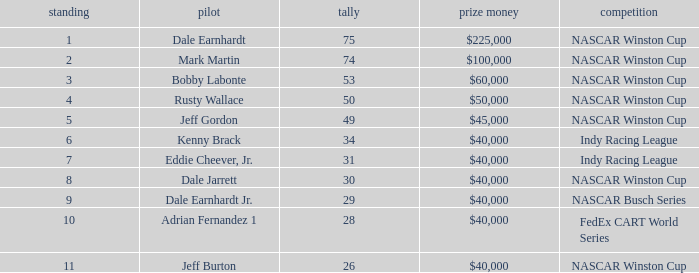How much did Kenny Brack win? $40,000. Give me the full table as a dictionary. {'header': ['standing', 'pilot', 'tally', 'prize money', 'competition'], 'rows': [['1', 'Dale Earnhardt', '75', '$225,000', 'NASCAR Winston Cup'], ['2', 'Mark Martin', '74', '$100,000', 'NASCAR Winston Cup'], ['3', 'Bobby Labonte', '53', '$60,000', 'NASCAR Winston Cup'], ['4', 'Rusty Wallace', '50', '$50,000', 'NASCAR Winston Cup'], ['5', 'Jeff Gordon', '49', '$45,000', 'NASCAR Winston Cup'], ['6', 'Kenny Brack', '34', '$40,000', 'Indy Racing League'], ['7', 'Eddie Cheever, Jr.', '31', '$40,000', 'Indy Racing League'], ['8', 'Dale Jarrett', '30', '$40,000', 'NASCAR Winston Cup'], ['9', 'Dale Earnhardt Jr.', '29', '$40,000', 'NASCAR Busch Series'], ['10', 'Adrian Fernandez 1', '28', '$40,000', 'FedEx CART World Series'], ['11', 'Jeff Burton', '26', '$40,000', 'NASCAR Winston Cup']]} 